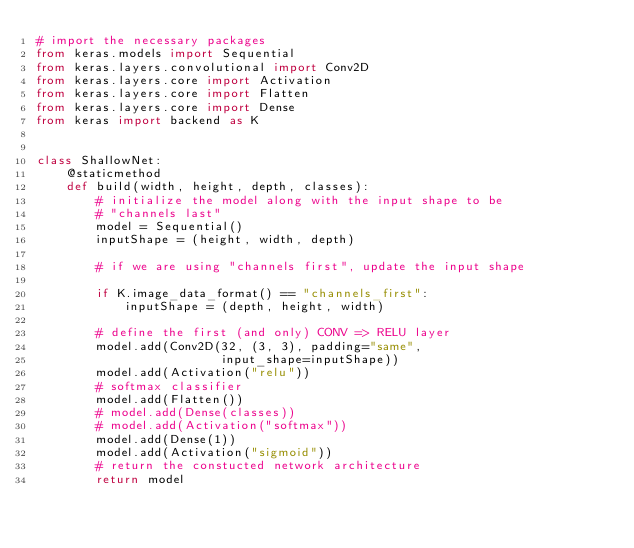Convert code to text. <code><loc_0><loc_0><loc_500><loc_500><_Python_># import the necessary packages
from keras.models import Sequential
from keras.layers.convolutional import Conv2D
from keras.layers.core import Activation
from keras.layers.core import Flatten
from keras.layers.core import Dense
from keras import backend as K


class ShallowNet:
    @staticmethod
    def build(width, height, depth, classes):
        # initialize the model along with the input shape to be
        # "channels last"
        model = Sequential()
        inputShape = (height, width, depth)

        # if we are using "channels first", update the input shape

        if K.image_data_format() == "channels_first":
            inputShape = (depth, height, width)

        # define the first (and only) CONV => RELU layer
        model.add(Conv2D(32, (3, 3), padding="same",
                         input_shape=inputShape))
        model.add(Activation("relu"))
        # softmax classifier
        model.add(Flatten())
        # model.add(Dense(classes))
        # model.add(Activation("softmax"))
        model.add(Dense(1))
        model.add(Activation("sigmoid"))
        # return the constucted network architecture
        return model


</code> 